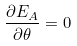Convert formula to latex. <formula><loc_0><loc_0><loc_500><loc_500>\frac { \partial E _ { A } } { \partial \theta } = 0</formula> 